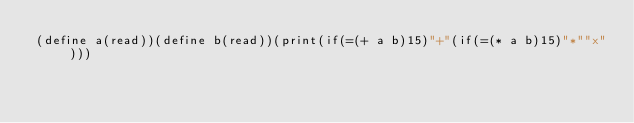Convert code to text. <code><loc_0><loc_0><loc_500><loc_500><_Scheme_>(define a(read))(define b(read))(print(if(=(+ a b)15)"+"(if(=(* a b)15)"*""x")))</code> 